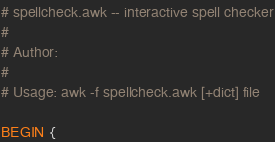Convert code to text. <code><loc_0><loc_0><loc_500><loc_500><_Awk_># spellcheck.awk -- interactive spell checker
#
# Author: 
#
# Usage: awk -f spellcheck.awk [+dict] file

BEGIN {</code> 